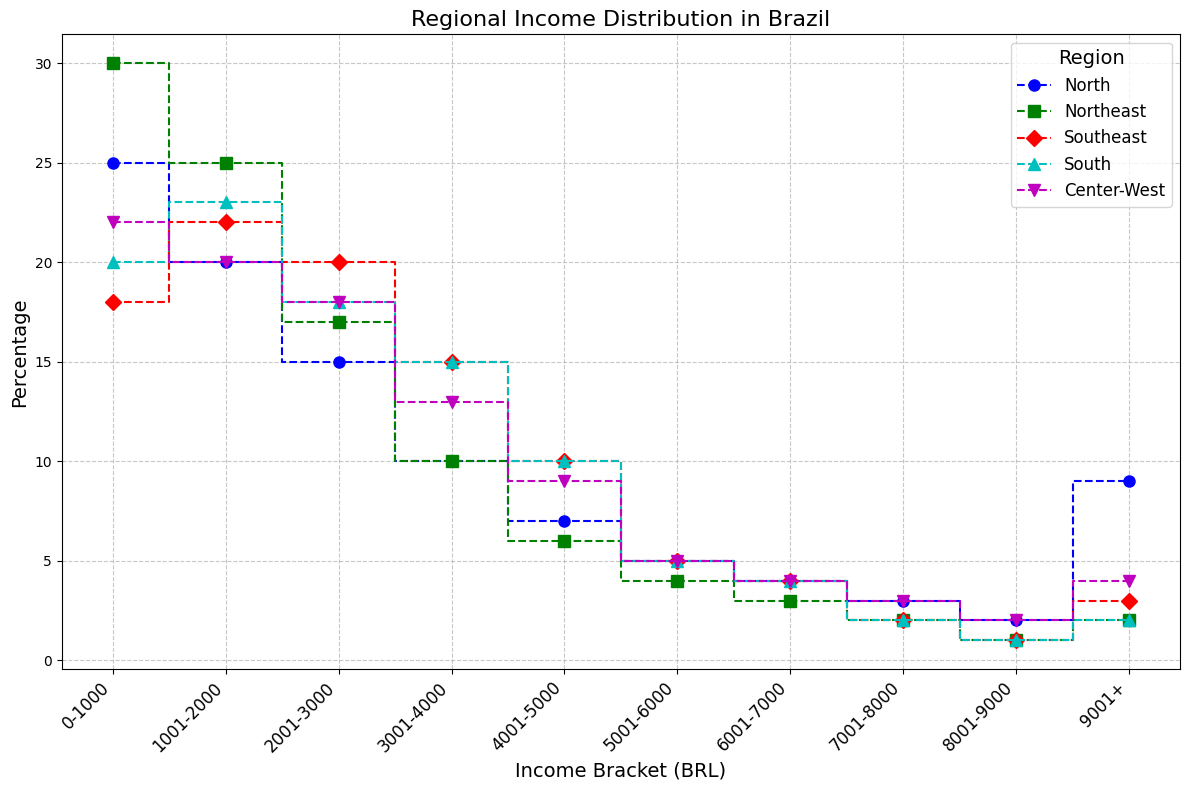What is the percentage of people in the North region earning between 0-1000 BRL? The percentage is directly visible from the plot where the North region curve starts at 25% for the 0-1000 BRL bracket.
Answer: 25% What is the combined percentage of people earning more than 5000 BRL in the Southeast region? Identify the percentage values for income brackets above 5000 BRL in the Southeast region and sum them up: 5% (5001-6000) + 4% (6001-7000) + 2% (7001-8000) + 1% (8001-9000) + 3% (9001+).
Answer: 15% Which region has the highest percentage of people earning between 2001-3000 BRL? Compare the values for the 2001-3000 BRL income bracket among all regions: 15% (North), 17% (Northeast), 20% (Southeast), 18% (South), 18% (Center-West). The Southeast has the highest at 20%.
Answer: Southeast How does the percentage of people earning 9001+ BRL in the Center-West compare to the North? Compare the numbers: Center-West is at 4%, while North is at 9%.
Answer: North has a higher percentage Which region has the steepest increase in the percentage of people earning between 0-1000 BRL to 1001-2000 BRL? The steepest increase can be seen from the slope of the steps between the two brackets. Examine the stepped lines for all regions. The Northeast goes from 30% to 25%, so the increase is 5%. North from 25% to 20%, 5%. Southeast from 18% to 22%, increase of 4%. South from 20% to 23%, increase of 3%. Center-West from 22% to 20%, decrease of 2%. The Northeast and the North have the steepest increases (5%).
Answer: Northeast and North What is the sum of percentages for the income brackets 4001-5000 BRL and 5001-6000 BRL in the South region? Add the percentages visible for the South region in these income brackets: 10% (4001-5000) + 5% (5001-6000).
Answer: 15% In which region is the longest flat line segment visible and for which income bracket? Identify the longest segment where the percentage value does not change. Notice the flat segment in the Northeast region between 8001-9000 BRL and 9001+, both at 1%.
Answer: Northeast for 8001-9000 BRL to 9001+ How does the income distribution in the North region compare visually to the South region? Compare the stairs plots of both regions. Notice the North region starts high and decreases more gradually, indicating a higher percentage of lower-income brackets, whereas the South has a steadier decrease, indicating a relatively even distribution across income brackets.
Answer: North has more lower-income, South is more even What is the difference in percentage between the highest and lowest income brackets in the Southeast? Identify the lowest (0-1000 BRL, 18%) and the highest (9001+, 3%) brackets from the plot. Calculate the difference: 18% - 3%.
Answer: 15% Which region sees a higher percentage of people moving from 3001-4000 BRL to 4001-5000 BRL: North or Southeast? Compare the transitions between these brackets: North 10% (3001-4000) to 7% (4001-5000), Southeast 15% (3001-4000) to 10% (4001-5000). The decrease for both is 3%, so they're equal.
Answer: Equal 